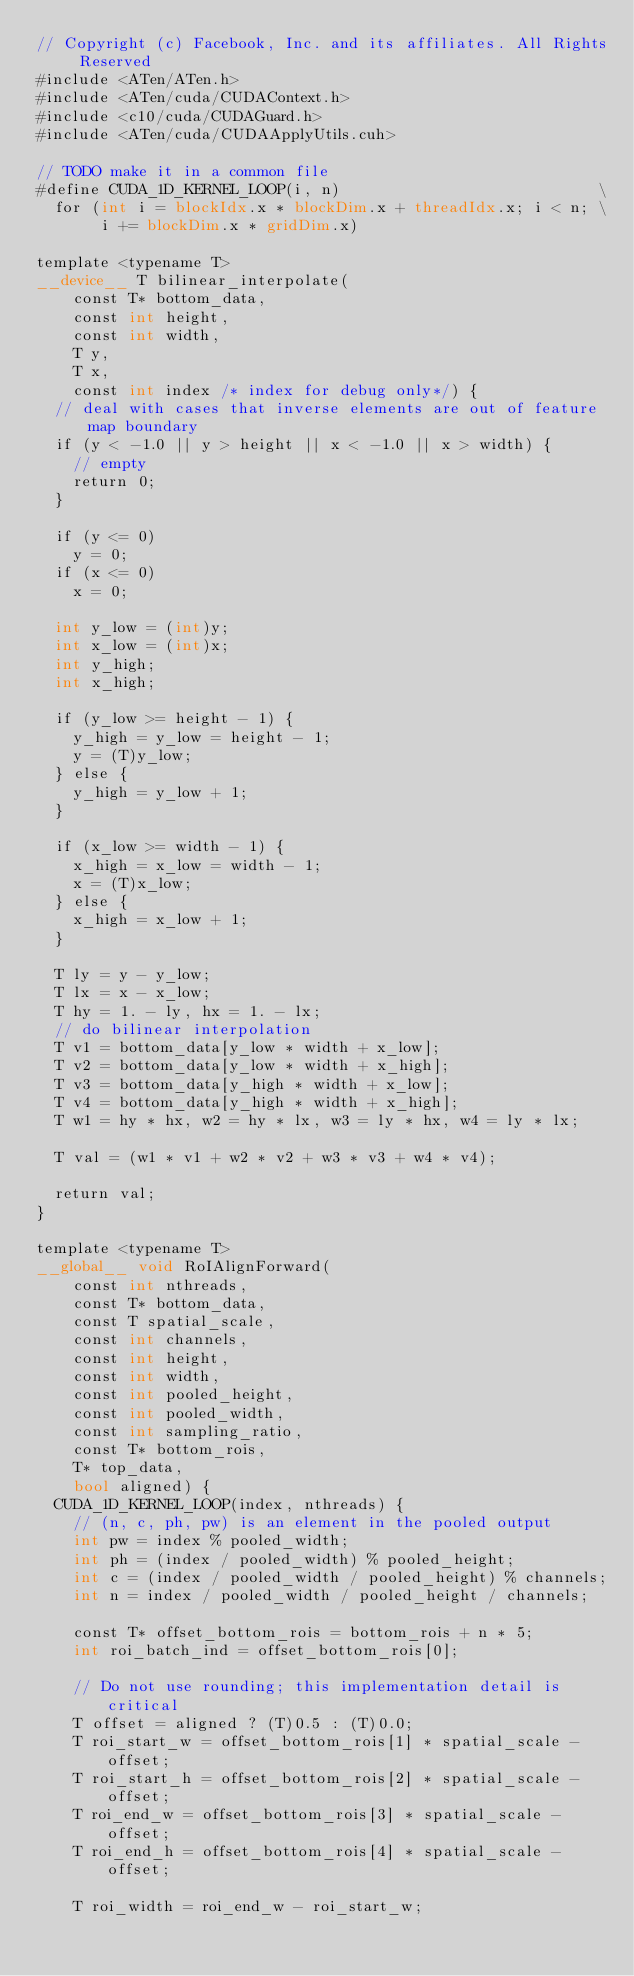<code> <loc_0><loc_0><loc_500><loc_500><_Cuda_>// Copyright (c) Facebook, Inc. and its affiliates. All Rights Reserved
#include <ATen/ATen.h>
#include <ATen/cuda/CUDAContext.h>
#include <c10/cuda/CUDAGuard.h>
#include <ATen/cuda/CUDAApplyUtils.cuh>

// TODO make it in a common file
#define CUDA_1D_KERNEL_LOOP(i, n)                            \
  for (int i = blockIdx.x * blockDim.x + threadIdx.x; i < n; \
       i += blockDim.x * gridDim.x)

template <typename T>
__device__ T bilinear_interpolate(
    const T* bottom_data,
    const int height,
    const int width,
    T y,
    T x,
    const int index /* index for debug only*/) {
  // deal with cases that inverse elements are out of feature map boundary
  if (y < -1.0 || y > height || x < -1.0 || x > width) {
    // empty
    return 0;
  }

  if (y <= 0)
    y = 0;
  if (x <= 0)
    x = 0;

  int y_low = (int)y;
  int x_low = (int)x;
  int y_high;
  int x_high;

  if (y_low >= height - 1) {
    y_high = y_low = height - 1;
    y = (T)y_low;
  } else {
    y_high = y_low + 1;
  }

  if (x_low >= width - 1) {
    x_high = x_low = width - 1;
    x = (T)x_low;
  } else {
    x_high = x_low + 1;
  }

  T ly = y - y_low;
  T lx = x - x_low;
  T hy = 1. - ly, hx = 1. - lx;
  // do bilinear interpolation
  T v1 = bottom_data[y_low * width + x_low];
  T v2 = bottom_data[y_low * width + x_high];
  T v3 = bottom_data[y_high * width + x_low];
  T v4 = bottom_data[y_high * width + x_high];
  T w1 = hy * hx, w2 = hy * lx, w3 = ly * hx, w4 = ly * lx;

  T val = (w1 * v1 + w2 * v2 + w3 * v3 + w4 * v4);

  return val;
}

template <typename T>
__global__ void RoIAlignForward(
    const int nthreads,
    const T* bottom_data,
    const T spatial_scale,
    const int channels,
    const int height,
    const int width,
    const int pooled_height,
    const int pooled_width,
    const int sampling_ratio,
    const T* bottom_rois,
    T* top_data,
    bool aligned) {
  CUDA_1D_KERNEL_LOOP(index, nthreads) {
    // (n, c, ph, pw) is an element in the pooled output
    int pw = index % pooled_width;
    int ph = (index / pooled_width) % pooled_height;
    int c = (index / pooled_width / pooled_height) % channels;
    int n = index / pooled_width / pooled_height / channels;

    const T* offset_bottom_rois = bottom_rois + n * 5;
    int roi_batch_ind = offset_bottom_rois[0];

    // Do not use rounding; this implementation detail is critical
    T offset = aligned ? (T)0.5 : (T)0.0;
    T roi_start_w = offset_bottom_rois[1] * spatial_scale - offset;
    T roi_start_h = offset_bottom_rois[2] * spatial_scale - offset;
    T roi_end_w = offset_bottom_rois[3] * spatial_scale - offset;
    T roi_end_h = offset_bottom_rois[4] * spatial_scale - offset;

    T roi_width = roi_end_w - roi_start_w;</code> 